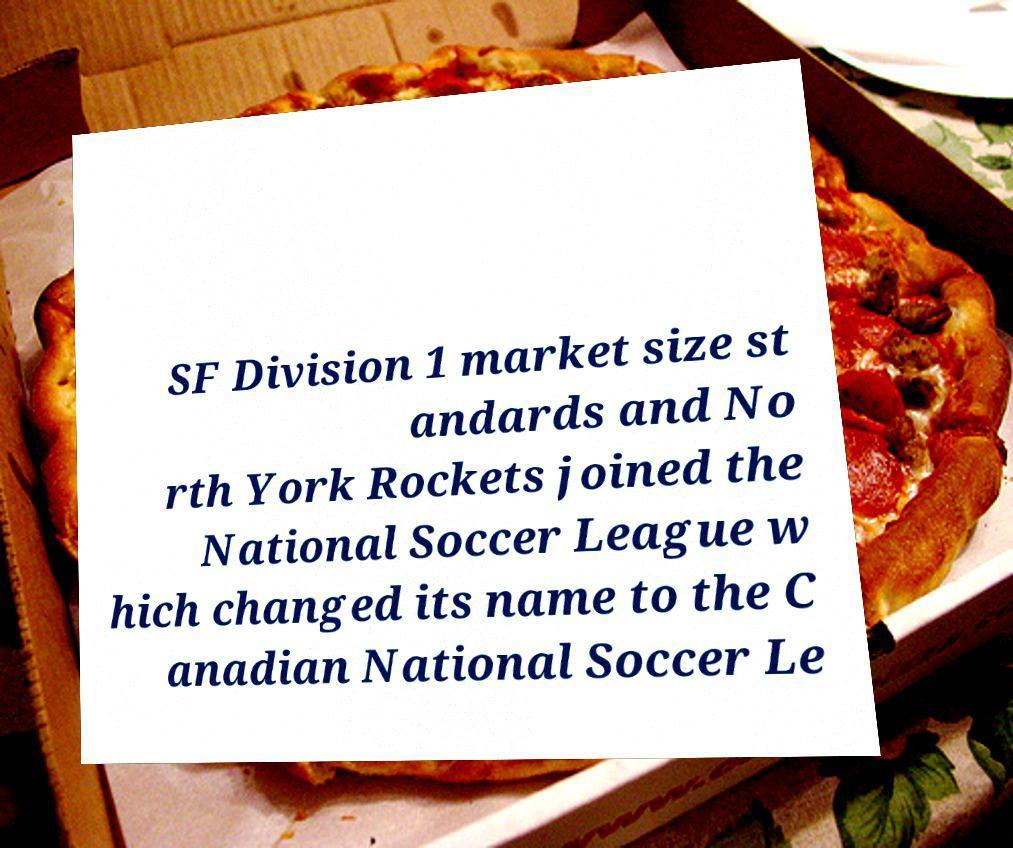For documentation purposes, I need the text within this image transcribed. Could you provide that? SF Division 1 market size st andards and No rth York Rockets joined the National Soccer League w hich changed its name to the C anadian National Soccer Le 